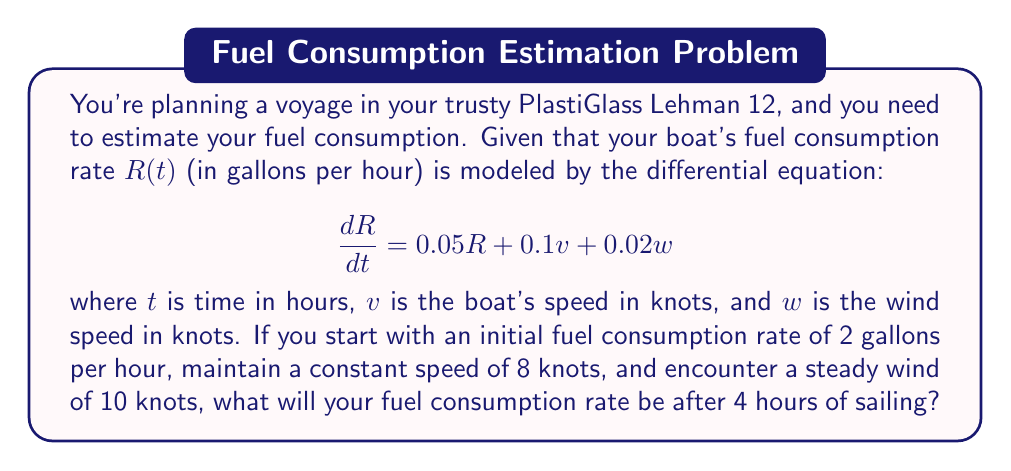Help me with this question. Let's approach this step-by-step:

1) We have a first-order linear differential equation:

   $$\frac{dR}{dt} = 0.05R + 0.1v + 0.02w$$

2) Given:
   - Initial rate $R(0) = 2$ gallons/hour
   - Constant boat speed $v = 8$ knots
   - Constant wind speed $w = 10$ knots

3) Substituting the constants:

   $$\frac{dR}{dt} = 0.05R + 0.1(8) + 0.02(10) = 0.05R + 1$$

4) This is now in the form $\frac{dR}{dt} = aR + b$, where $a = 0.05$ and $b = 1$.

5) The general solution for this type of equation is:

   $$R(t) = Ce^{at} - \frac{b}{a}$$

   where $C$ is a constant we need to determine.

6) Substituting our values:

   $$R(t) = Ce^{0.05t} - \frac{1}{0.05} = Ce^{0.05t} - 20$$

7) Using the initial condition $R(0) = 2$:

   $$2 = Ce^{0.05(0)} - 20$$
   $$2 = C - 20$$
   $$C = 22$$

8) Our particular solution is:

   $$R(t) = 22e^{0.05t} - 20$$

9) To find the rate after 4 hours, we evaluate $R(4)$:

   $$R(4) = 22e^{0.05(4)} - 20$$
   $$R(4) = 22e^{0.2} - 20$$
   $$R(4) = 22(1.2214) - 20$$
   $$R(4) = 26.8708 - 20 = 6.8708$$

Therefore, after 4 hours, the fuel consumption rate will be approximately 6.87 gallons per hour.
Answer: $6.87$ gallons per hour (rounded to two decimal places) 